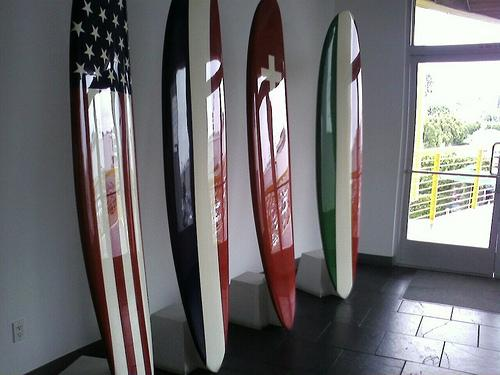What theme seems to have inspired the painting of the surfboards? country flags 